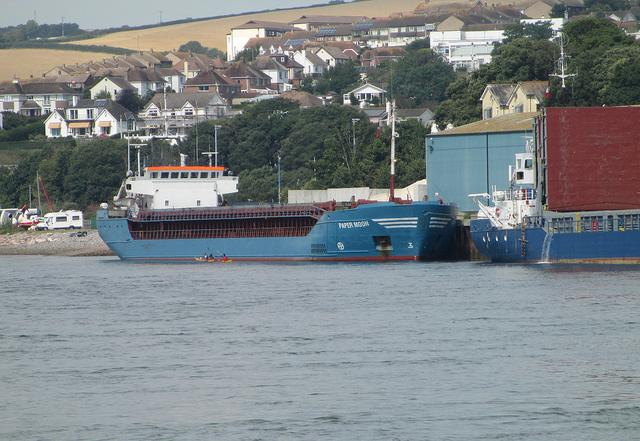What might live in this environment? fish 